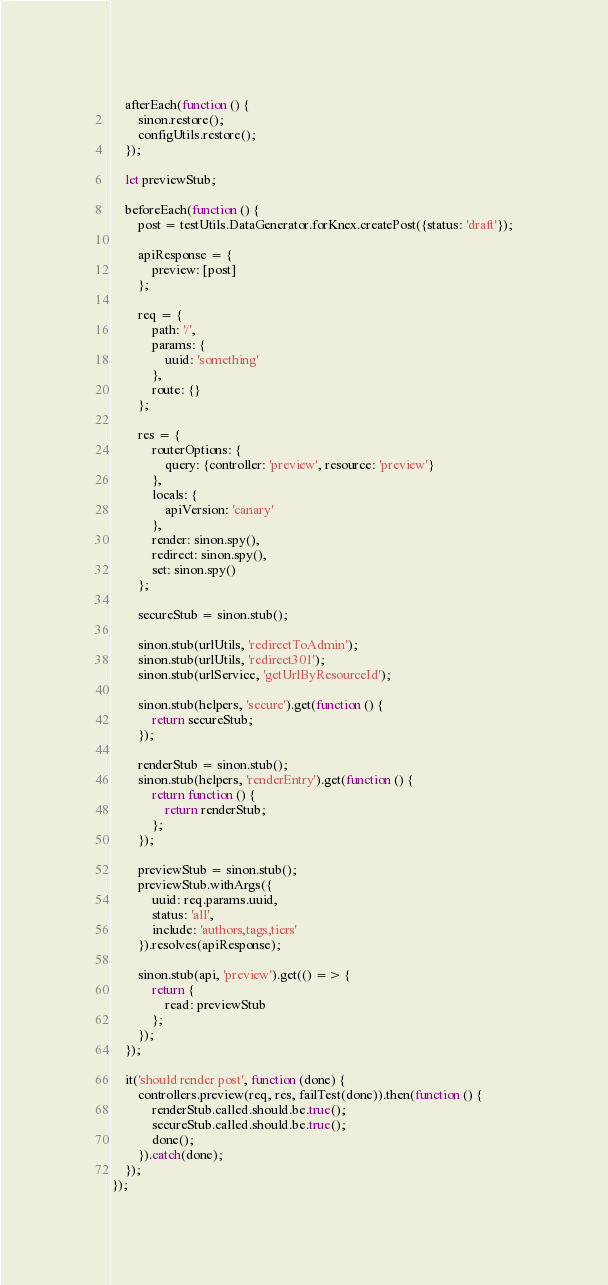<code> <loc_0><loc_0><loc_500><loc_500><_JavaScript_>    afterEach(function () {
        sinon.restore();
        configUtils.restore();
    });

    let previewStub;

    beforeEach(function () {
        post = testUtils.DataGenerator.forKnex.createPost({status: 'draft'});

        apiResponse = {
            preview: [post]
        };

        req = {
            path: '/',
            params: {
                uuid: 'something'
            },
            route: {}
        };

        res = {
            routerOptions: {
                query: {controller: 'preview', resource: 'preview'}
            },
            locals: {
                apiVersion: 'canary'
            },
            render: sinon.spy(),
            redirect: sinon.spy(),
            set: sinon.spy()
        };

        secureStub = sinon.stub();

        sinon.stub(urlUtils, 'redirectToAdmin');
        sinon.stub(urlUtils, 'redirect301');
        sinon.stub(urlService, 'getUrlByResourceId');

        sinon.stub(helpers, 'secure').get(function () {
            return secureStub;
        });

        renderStub = sinon.stub();
        sinon.stub(helpers, 'renderEntry').get(function () {
            return function () {
                return renderStub;
            };
        });

        previewStub = sinon.stub();
        previewStub.withArgs({
            uuid: req.params.uuid,
            status: 'all',
            include: 'authors,tags,tiers'
        }).resolves(apiResponse);

        sinon.stub(api, 'preview').get(() => {
            return {
                read: previewStub
            };
        });
    });

    it('should render post', function (done) {
        controllers.preview(req, res, failTest(done)).then(function () {
            renderStub.called.should.be.true();
            secureStub.called.should.be.true();
            done();
        }).catch(done);
    });
});
</code> 